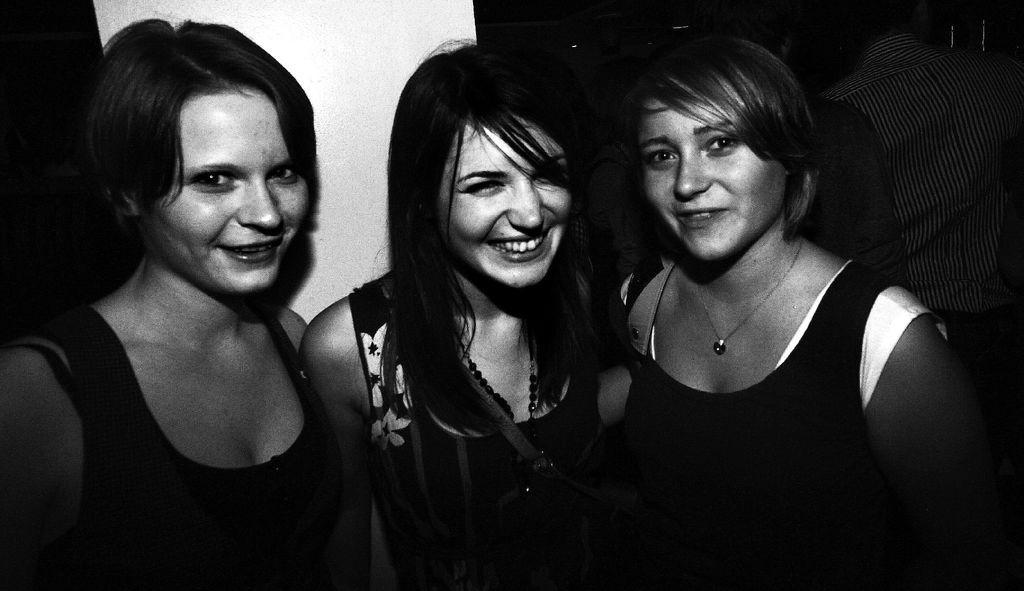Describe this image in one or two sentences. This is a black and white image. In the center of the image there are three girls. In the background of the image there is wall. There are people. 